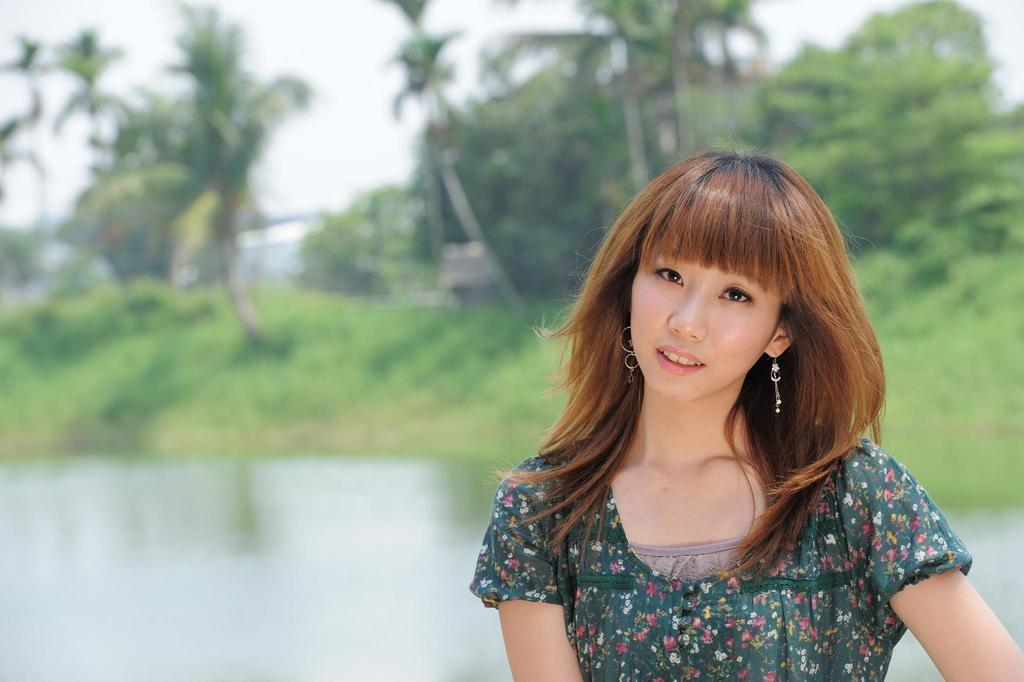What is present in the image? There is a person in the image. What is the person wearing? The person is wearing a green dress. What can be seen in the background of the image? There are trees and water visible in the background of the image. What type of pancake is being prepared in the image? There is no pancake present in the image. What time of day is it in the image? The time of day is not specified in the image. 